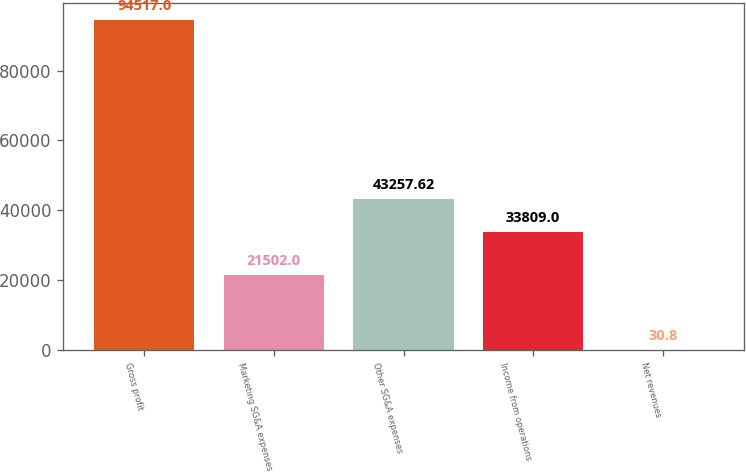Convert chart. <chart><loc_0><loc_0><loc_500><loc_500><bar_chart><fcel>Gross profit<fcel>Marketing SG&A expenses<fcel>Other SG&A expenses<fcel>Income from operations<fcel>Net revenues<nl><fcel>94517<fcel>21502<fcel>43257.6<fcel>33809<fcel>30.8<nl></chart> 